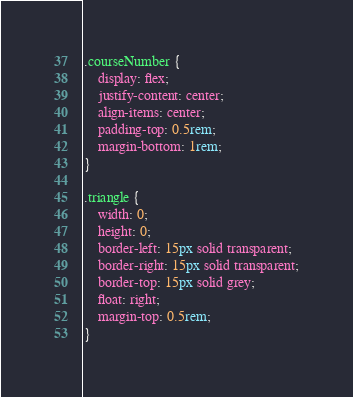<code> <loc_0><loc_0><loc_500><loc_500><_CSS_>
.courseNumber {
    display: flex;
    justify-content: center;
    align-items: center;
    padding-top: 0.5rem;
    margin-bottom: 1rem;
}

.triangle {
    width: 0; 
    height: 0; 
    border-left: 15px solid transparent;
    border-right: 15px solid transparent;
    border-top: 15px solid grey;
    float: right;
    margin-top: 0.5rem;
}</code> 